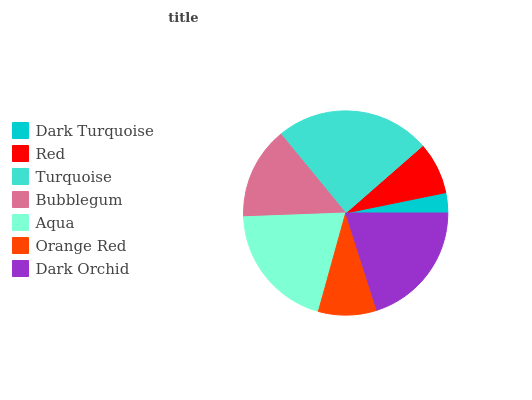Is Dark Turquoise the minimum?
Answer yes or no. Yes. Is Turquoise the maximum?
Answer yes or no. Yes. Is Red the minimum?
Answer yes or no. No. Is Red the maximum?
Answer yes or no. No. Is Red greater than Dark Turquoise?
Answer yes or no. Yes. Is Dark Turquoise less than Red?
Answer yes or no. Yes. Is Dark Turquoise greater than Red?
Answer yes or no. No. Is Red less than Dark Turquoise?
Answer yes or no. No. Is Bubblegum the high median?
Answer yes or no. Yes. Is Bubblegum the low median?
Answer yes or no. Yes. Is Red the high median?
Answer yes or no. No. Is Dark Orchid the low median?
Answer yes or no. No. 